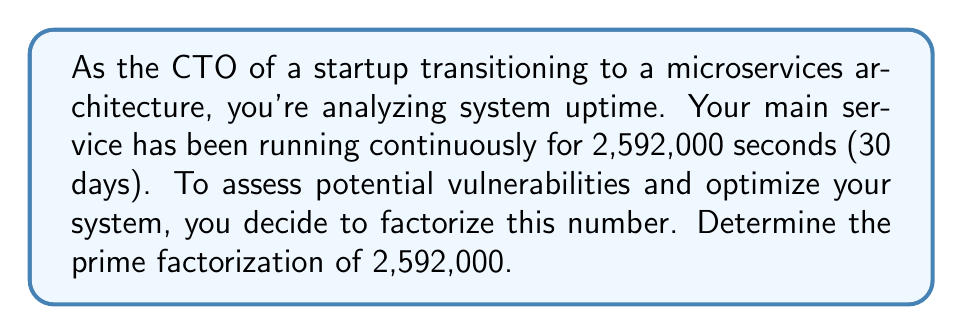Help me with this question. Let's approach this step-by-step:

1) First, let's start dividing by the smallest prime number, 2:

   $2,592,000 = 2 \times 1,296,000$
   $1,296,000 = 2 \times 648,000$
   $648,000 = 2 \times 324,000$
   $324,000 = 2 \times 162,000$
   $162,000 = 2 \times 81,000$

2) We've divided by 2 five times. Now let's try the next prime number, 3:

   $81,000 = 3 \times 27,000$
   $27,000 = 3 \times 9,000$
   $9,000 = 3 \times 3,000$
   $3,000 = 3 \times 1,000$

3) We've divided by 3 four times. The next number to try is 5:

   $1,000 = 5 \times 200$
   $200 = 5 \times 40$

4) We've divided by 5 twice. Let's continue:

   $40 = 2 \times 20$
   $20 = 2 \times 10$
   $10 = 2 \times 5$

5) We're left with 5, which is prime.

6) Now, let's combine all these factors:

   $2,592,000 = 2^5 \times 3^4 \times 5^3$

This prime factorization represents the fundamental building blocks of your system uptime in seconds, which could be useful for identifying patterns or potential optimization points in your microservices architecture.
Answer: $$2,592,000 = 2^5 \times 3^4 \times 5^3$$ 